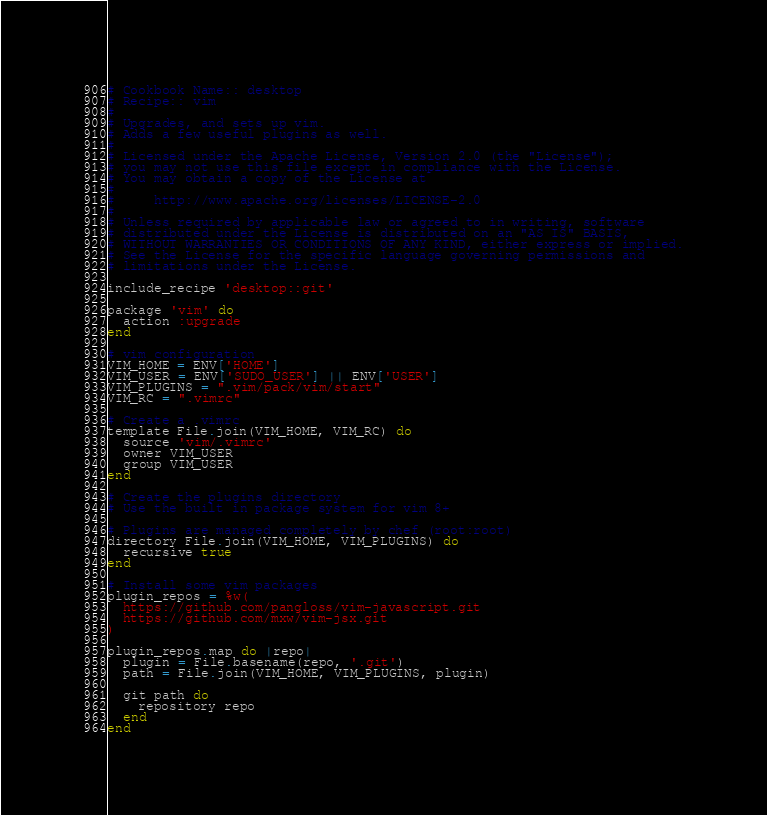<code> <loc_0><loc_0><loc_500><loc_500><_Ruby_># Cookbook Name:: desktop
# Recipe:: vim
#
# Upgrades, and sets up vim.
# Adds a few useful plugins as well.
#
# Licensed under the Apache License, Version 2.0 (the "License");
# you may not use this file except in compliance with the License.
# You may obtain a copy of the License at
#
#     http://www.apache.org/licenses/LICENSE-2.0
#
# Unless required by applicable law or agreed to in writing, software
# distributed under the License is distributed on an "AS IS" BASIS,
# WITHOUT WARRANTIES OR CONDITIONS OF ANY KIND, either express or implied.
# See the License for the specific language governing permissions and
# limitations under the License.

include_recipe 'desktop::git'

package 'vim' do
  action :upgrade
end

# vim configuration
VIM_HOME = ENV['HOME']
VIM_USER = ENV['SUDO_USER'] || ENV['USER']
VIM_PLUGINS = ".vim/pack/vim/start"
VIM_RC = ".vimrc"

# Create a .vimrc
template File.join(VIM_HOME, VIM_RC) do
  source 'vim/.vimrc'
  owner VIM_USER
  group VIM_USER
end

# Create the plugins directory
# Use the built in package system for vim 8+

# Plugins are managed completely by chef (root:root)
directory File.join(VIM_HOME, VIM_PLUGINS) do
  recursive true
end

# Install some vim packages
plugin_repos = %w(
  https://github.com/pangloss/vim-javascript.git
  https://github.com/mxw/vim-jsx.git
)

plugin_repos.map do |repo|
  plugin = File.basename(repo, '.git')
  path = File.join(VIM_HOME, VIM_PLUGINS, plugin)

  git path do
    repository repo
  end
end

</code> 